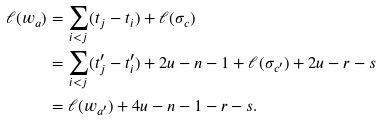Convert formula to latex. <formula><loc_0><loc_0><loc_500><loc_500>\ell ( w _ { a } ) & = \sum _ { i < j } ( t _ { j } - t _ { i } ) + \ell ( \sigma _ { c } ) \\ & = \sum _ { i < j } ( t ^ { \prime } _ { j } - t ^ { \prime } _ { i } ) + 2 u - n - 1 + \ell ( \sigma _ { c ^ { \prime } } ) + 2 u - r - s \\ & = \ell ( w _ { a ^ { \prime } } ) + 4 u - n - 1 - r - s .</formula> 